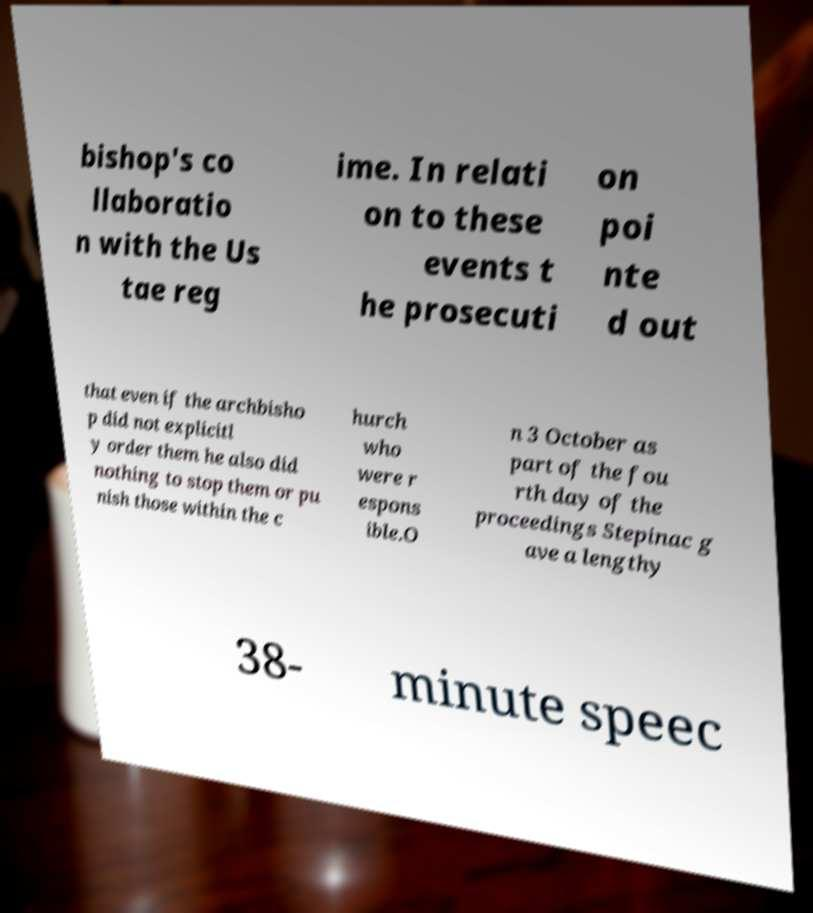Could you assist in decoding the text presented in this image and type it out clearly? bishop's co llaboratio n with the Us tae reg ime. In relati on to these events t he prosecuti on poi nte d out that even if the archbisho p did not explicitl y order them he also did nothing to stop them or pu nish those within the c hurch who were r espons ible.O n 3 October as part of the fou rth day of the proceedings Stepinac g ave a lengthy 38- minute speec 